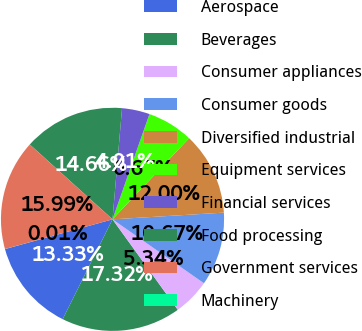Convert chart to OTSL. <chart><loc_0><loc_0><loc_500><loc_500><pie_chart><fcel>Aerospace<fcel>Beverages<fcel>Consumer appliances<fcel>Consumer goods<fcel>Diversified industrial<fcel>Equipment services<fcel>Financial services<fcel>Food processing<fcel>Government services<fcel>Machinery<nl><fcel>13.33%<fcel>17.32%<fcel>5.34%<fcel>10.67%<fcel>12.0%<fcel>6.67%<fcel>4.01%<fcel>14.66%<fcel>15.99%<fcel>0.01%<nl></chart> 